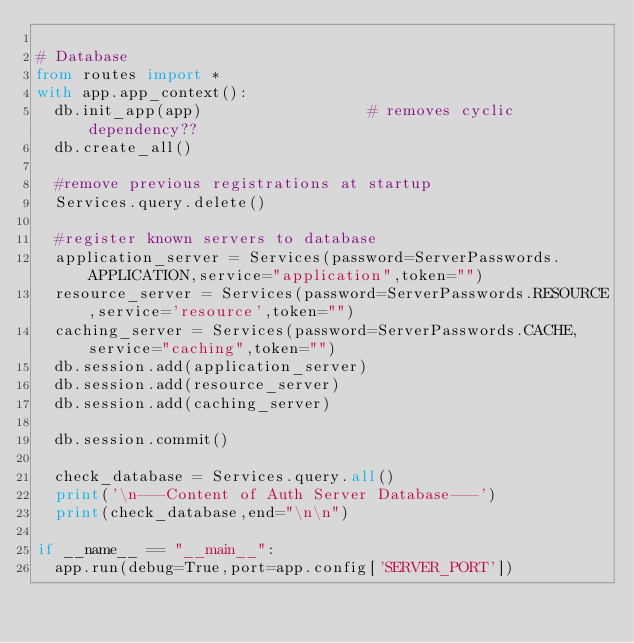<code> <loc_0><loc_0><loc_500><loc_500><_Python_>
# Database
from routes import *
with app.app_context():
	db.init_app(app)									# removes cyclic dependency??
	db.create_all()

	#remove previous registrations at startup
	Services.query.delete()

	#register known servers to database
	application_server = Services(password=ServerPasswords.APPLICATION,service="application",token="")
	resource_server = Services(password=ServerPasswords.RESOURCE,service='resource',token="")
	caching_server = Services(password=ServerPasswords.CACHE,service="caching",token="")
	db.session.add(application_server)
	db.session.add(resource_server)
	db.session.add(caching_server)
	
	db.session.commit()

	check_database = Services.query.all()
	print('\n---Content of Auth Server Database---')
	print(check_database,end="\n\n")

if __name__ == "__main__":
	app.run(debug=True,port=app.config['SERVER_PORT']) </code> 